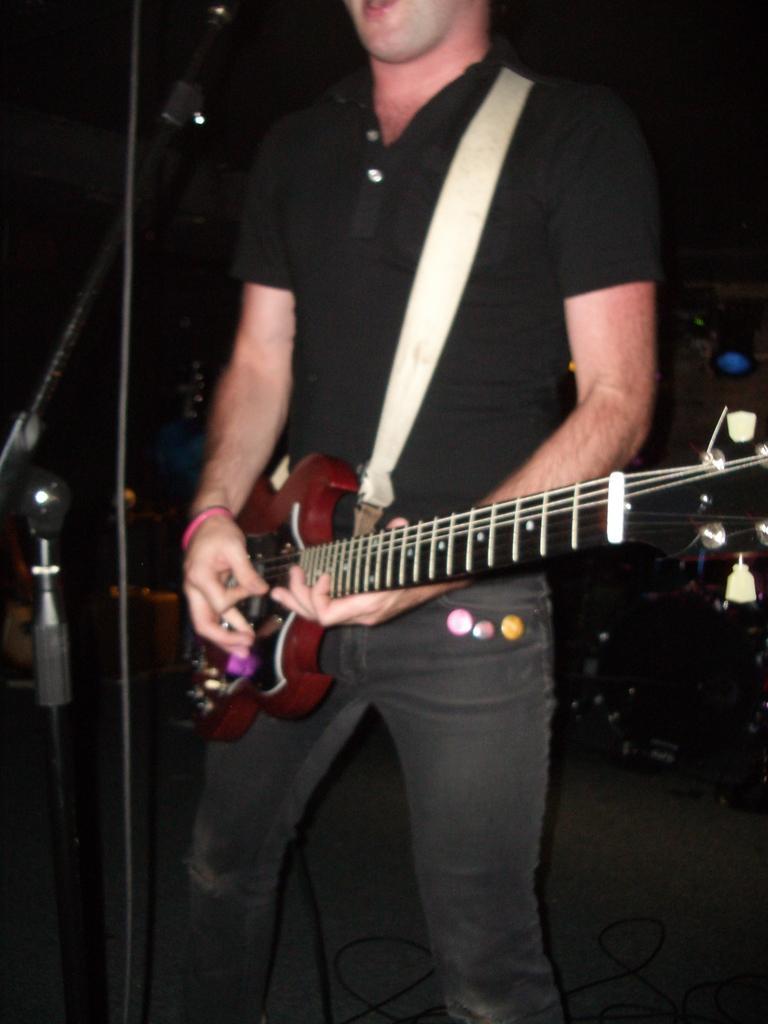Can you describe this image briefly? In this image we can see a person playing guitar, in front of him there is a mic and a stand, the background is dark. 